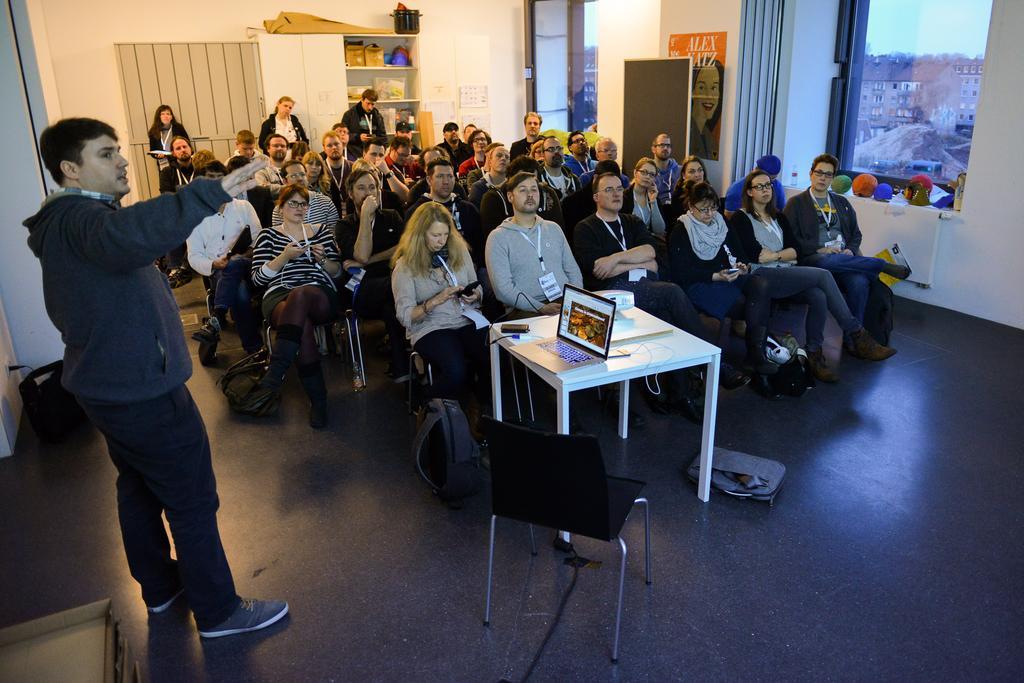Please provide a concise description of this image. In this picture we can see a group of people on the ground and some people are sitting on chairs and some people are standing, here we can see a table, laptop, wall, shelves, windows, curtain and some objects and in the background we can see buildings and the sky. 